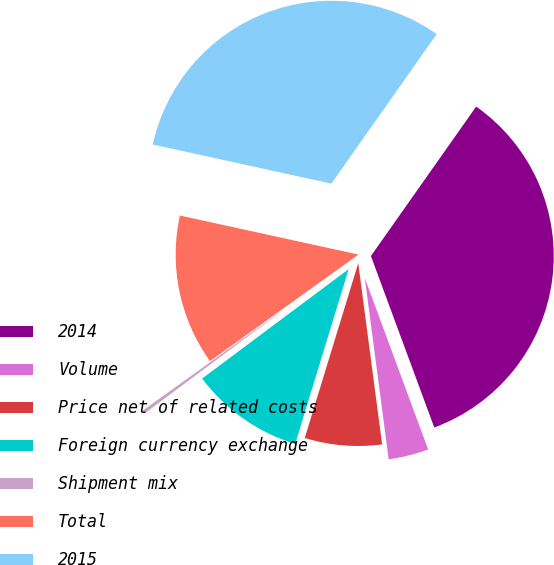Convert chart. <chart><loc_0><loc_0><loc_500><loc_500><pie_chart><fcel>2014<fcel>Volume<fcel>Price net of related costs<fcel>Foreign currency exchange<fcel>Shipment mix<fcel>Total<fcel>2015<nl><fcel>34.6%<fcel>3.55%<fcel>6.81%<fcel>10.07%<fcel>0.3%<fcel>13.33%<fcel>31.34%<nl></chart> 